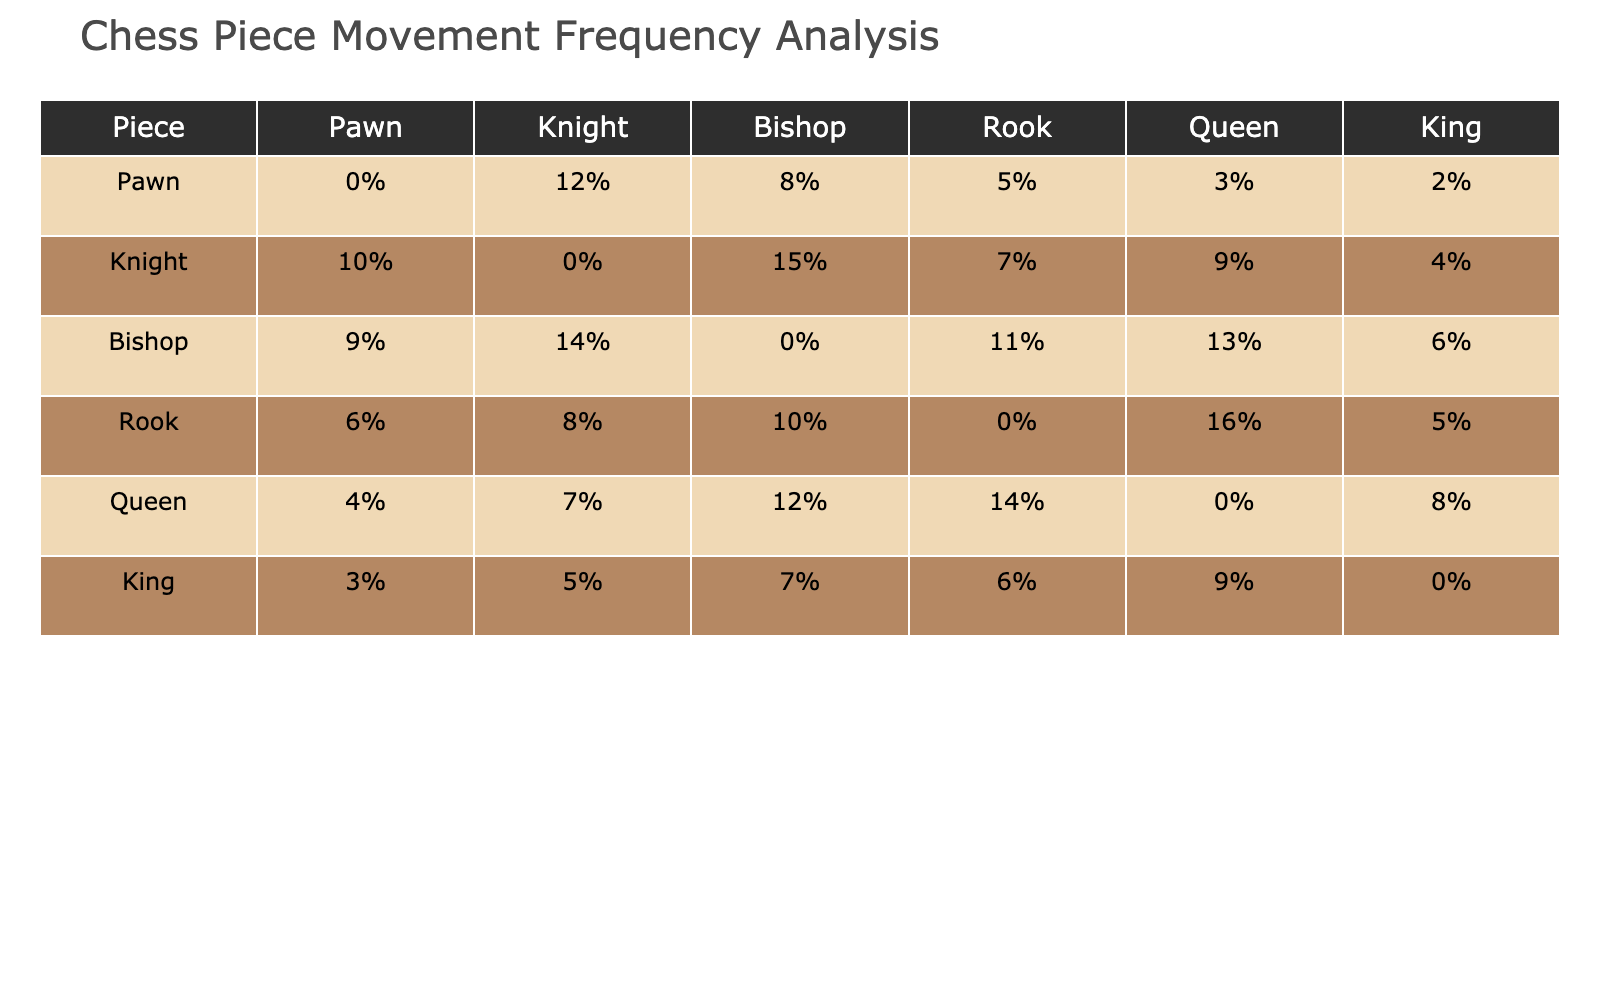What's the movement frequency percentage of the Knight? The Knight's movement frequency percentage is found in the row labeled 'Knight' and the column labels. The corresponding percentage is 0% compared to itself and various percentages against other pieces, with notable mentions being 10% towards Pawn and 15% towards Bishop.
Answer: 0% Which piece has the highest movement frequency against the Rook? To find the highest movement frequency against the Rook, we check the Rook's row and look for the maximum value among the other pieces. The Queen has the highest percentage against the Rook at 14%.
Answer: 14% Between the Bishop and the Queen, which piece interacts more with the Knight? We compare the values in the Knight's column for both the Bishop (15%) and the Queen (9%). The Bishop has a higher interaction frequency.
Answer: Bishop What is the total movement percentage of the Pawn against all pieces combined? To find this out, we sum all percentages in the Pawn's row: 0% + 12% + 8% + 5% + 3% + 2% = 30%.
Answer: 30% Is it true that the King moves less frequently than the Rook against the Bishop? We compare the King and Rook's percentages against the Bishop. The King moves 7% while the Rook moves 10%. Since 7% is less than 10%, the statement is true.
Answer: Yes What is the average interaction frequency of the Queen with all other pieces? We add the interaction percentages for the Queen (4% + 7% + 12% + 14% + 8%) which equals 45%. Then we divide by the number of pieces it interacts with, which is 5 (not including itself). So, the average is 45% / 5 = 9%.
Answer: 9% Which piece has the lowest overall movement frequency against another piece? We need to identify the lowest percentages in each row. The Pawn has a frequency of 0% against itself and all other pieces have values greater than 0% against themselves, making it the piece with the lowest overall interaction.
Answer: Pawn If the Bishop's interaction with the Knight was doubled, what would its new movement frequency against the Knight be? The current movement frequency of the Bishop against the Knight is 14%. If doubled, the new frequency would be 14% * 2 = 28%.
Answer: 28% What percentage of interactions does the Queen have against the King compared to its maximum interaction? The Queen has 8% interaction with the King, and its maximum interaction is 14% against the Rook. The percentage of the King's interaction relative to the maximum is (8% / 14%) * 100 = 57.14%.
Answer: 57.14% How does the interaction frequency of the Rook with the Queen differ from its interaction with the King? The interaction frequency of the Rook with the Queen is 14% and with the King is 5%. The difference is 14% - 5% = 9%.
Answer: 9% 